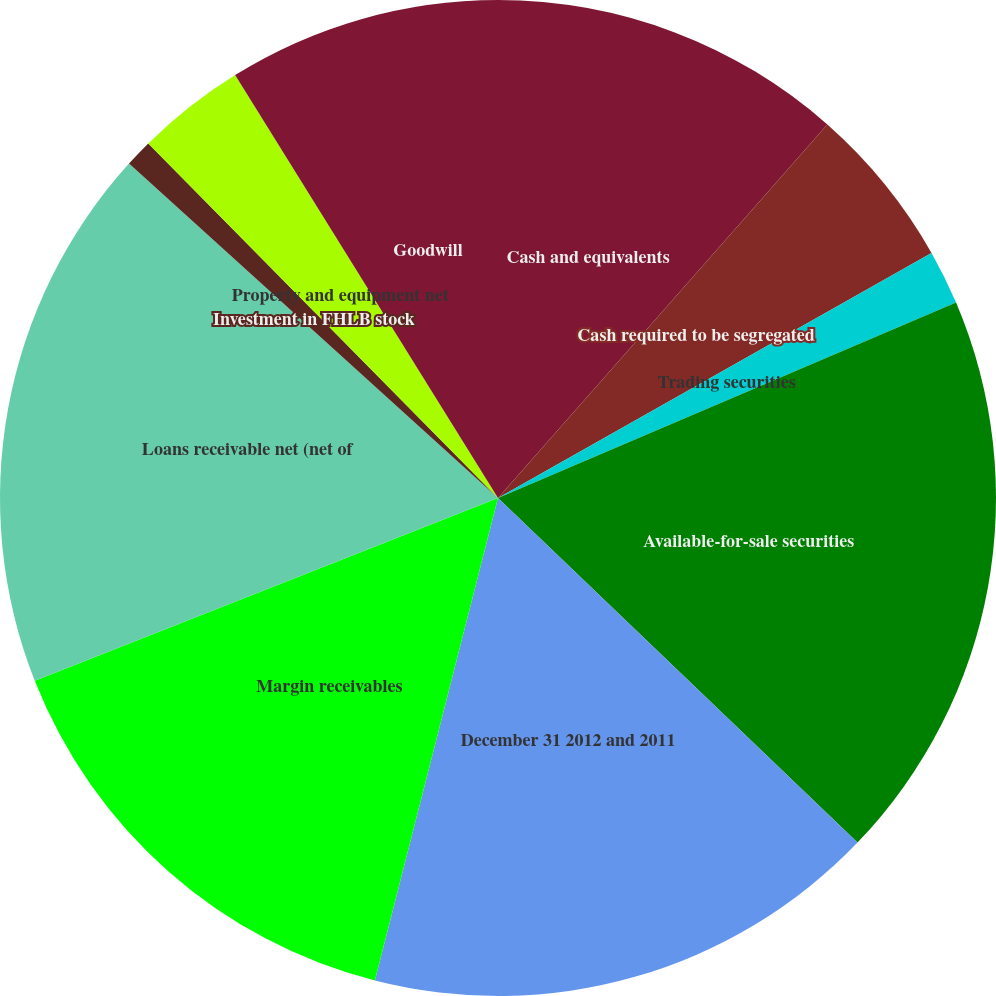Convert chart. <chart><loc_0><loc_0><loc_500><loc_500><pie_chart><fcel>Cash and equivalents<fcel>Cash required to be segregated<fcel>Trading securities<fcel>Available-for-sale securities<fcel>December 31 2012 and 2011<fcel>Margin receivables<fcel>Loans receivable net (net of<fcel>Investment in FHLB stock<fcel>Property and equipment net<fcel>Goodwill<nl><fcel>11.5%<fcel>5.31%<fcel>1.77%<fcel>18.58%<fcel>16.81%<fcel>15.04%<fcel>17.7%<fcel>0.89%<fcel>3.54%<fcel>8.85%<nl></chart> 